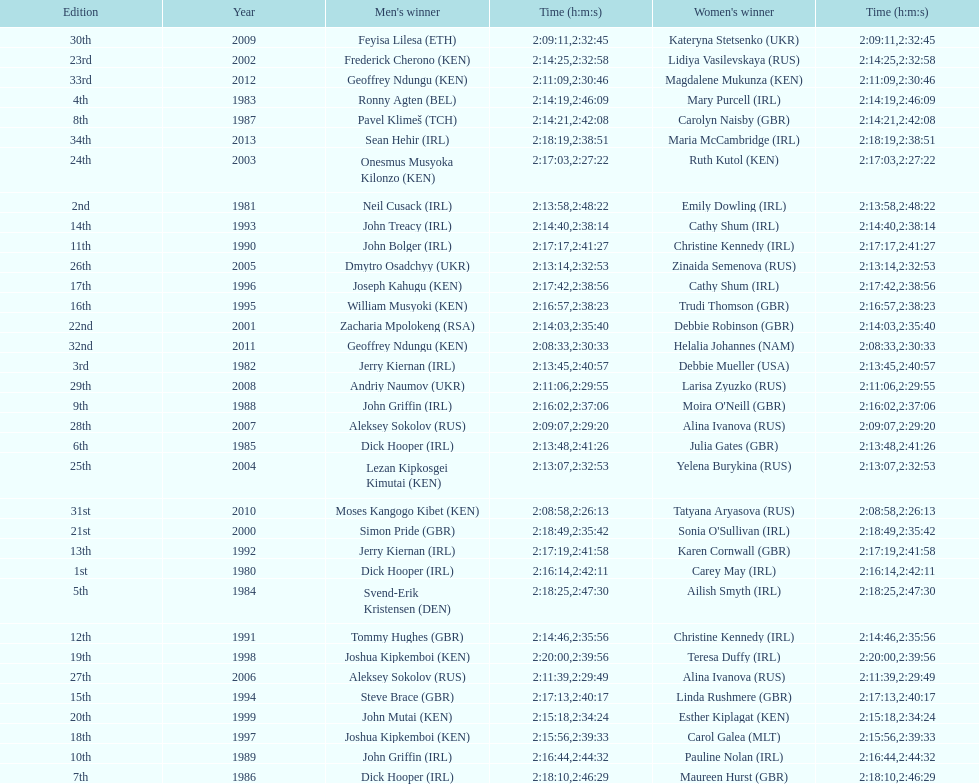Who had the most amount of time out of all the runners? Maria McCambridge (IRL). 